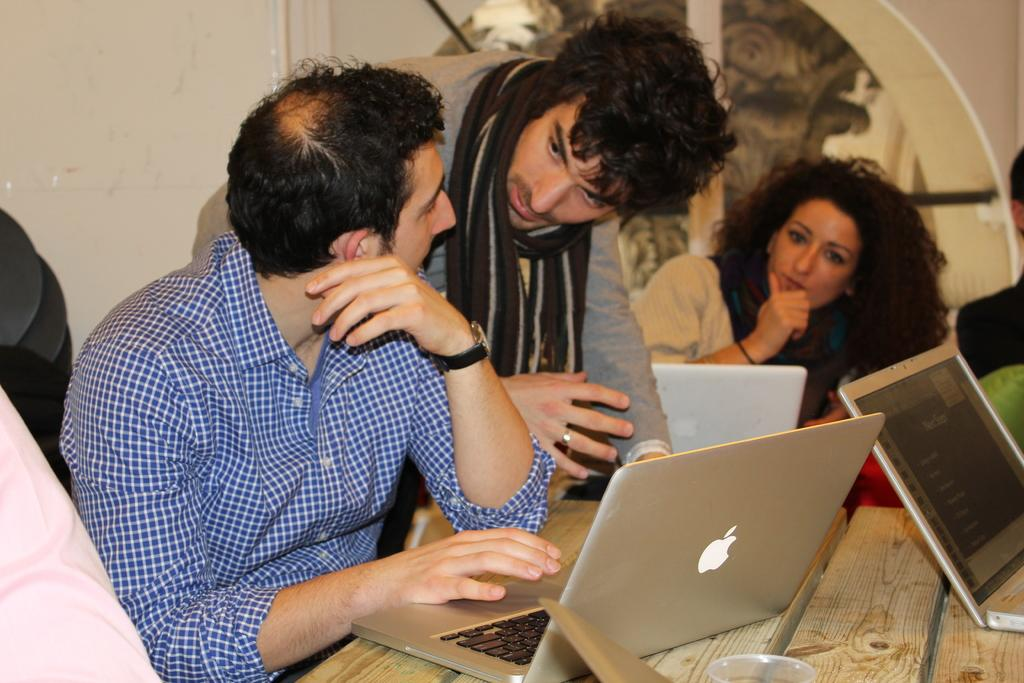How many people are in the image? There are people in the image, but the exact number is not specified. What are the people doing in the image? Some people are sitting, and one person is standing. What is on the table in the image? There are laptops and a glass on the table. What might the people be using the laptops for? The people might be using the laptops for work, studying, or leisure activities. What type of beef is being served on the cart in the image? There is no beef or cart present in the image. How many people are sitting on the person in the image? The image does not depict any people sitting on other people. 